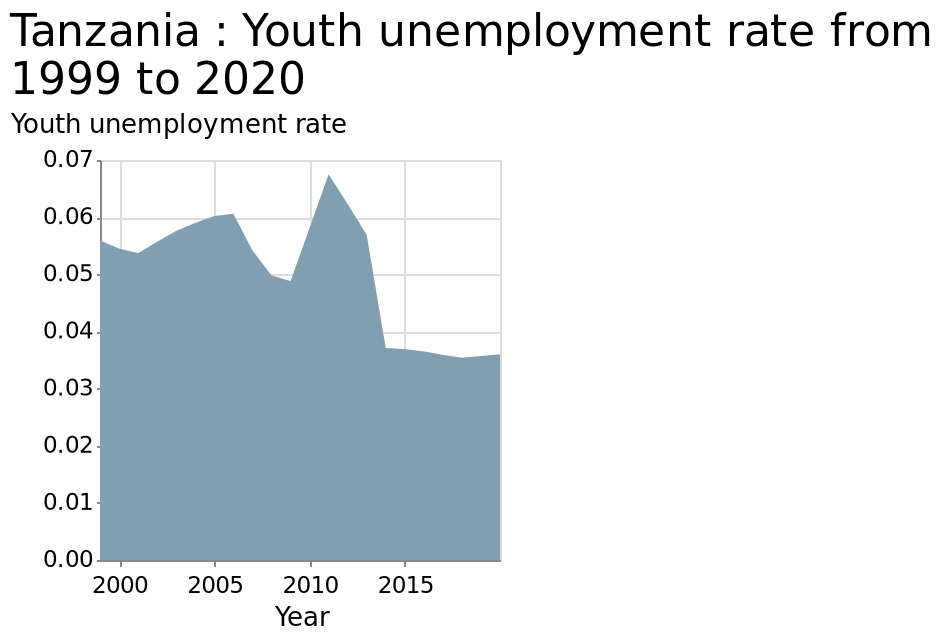<image>
When did youth unemployment reach its all-time low? Youth unemployment reached its all-time low in 2014. 